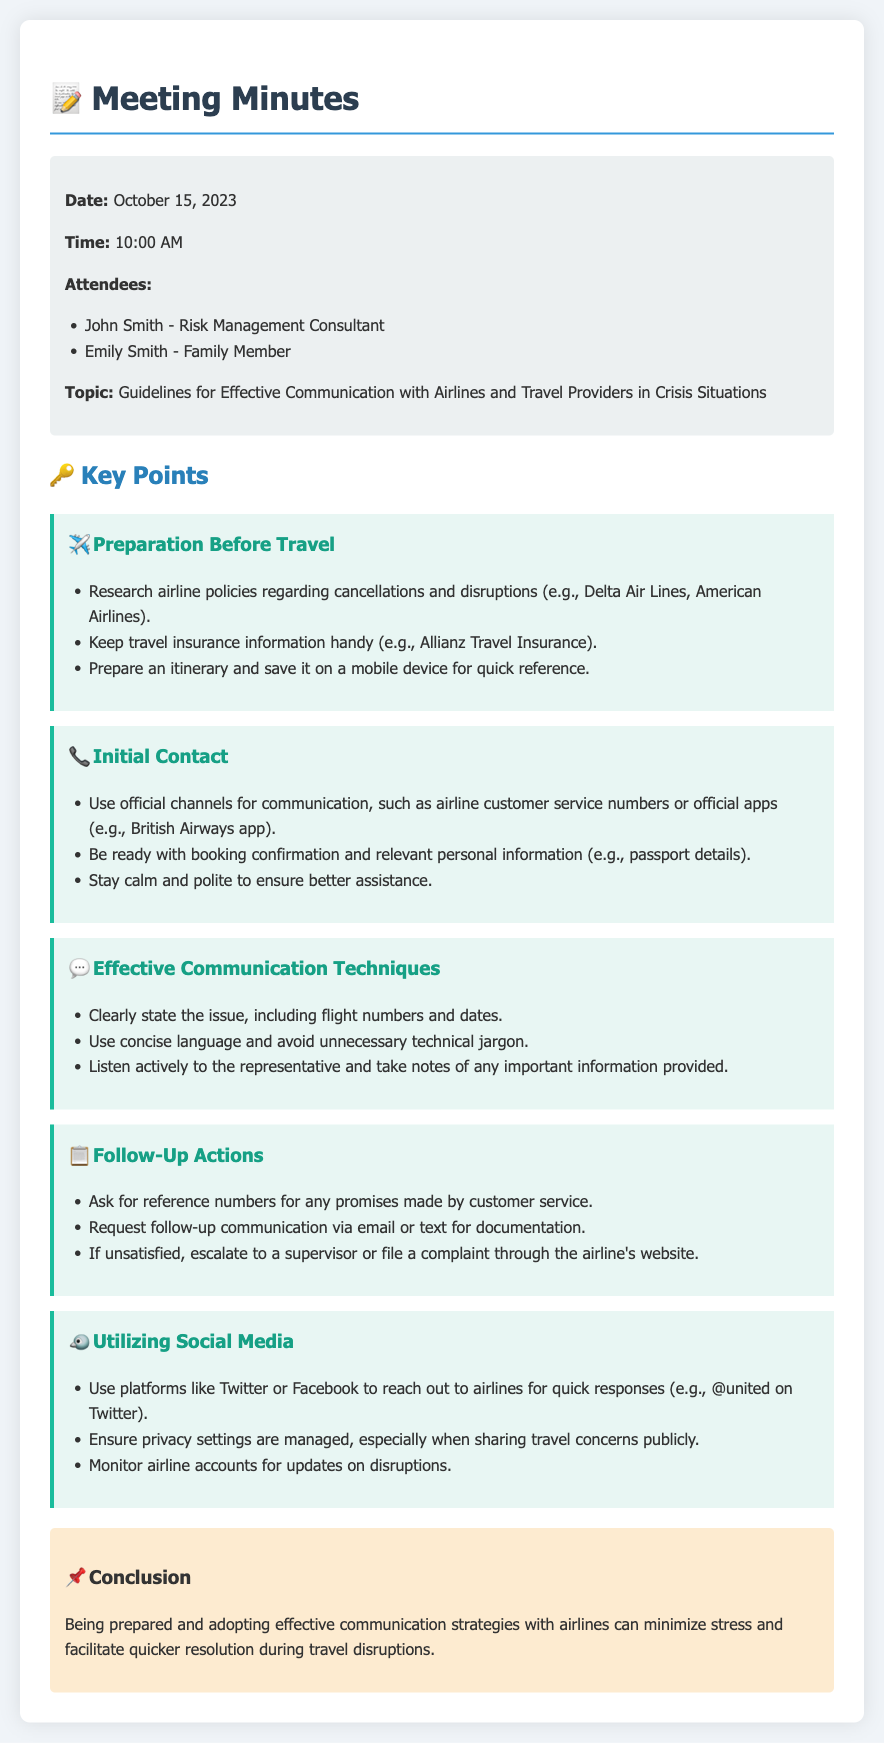what is the date of the meeting? The date of the meeting is stated in the meta-info section of the document.
Answer: October 15, 2023 who is one of the attendees? The names of attendees are listed under the meta-info section.
Answer: John Smith what is one communication channel recommended for initial contact? The document specifies using official channels for communication.
Answer: airline customer service numbers what should you keep handy before travel? The guidelines highlight the importance of keeping certain information accessible before travel.
Answer: travel insurance information what should you request for follow-up actions? The follow-up actions section advises on specific documentation to ask for.
Answer: reference numbers how can social media be utilized in crisis situations? The document outlines how social media can assist in reaching out to airlines.
Answer: quick responses what is a key effective communication technique? The document lists techniques for effective communication, including a crucial action to take.
Answer: Listen actively what should be avoided during communication? The guidelines mention avoiding certain types of language in communication.
Answer: unnecessary technical jargon what is the conclusion of the meeting minutes? The conclusion summarizes the overall advice given during the meeting.
Answer: Being prepared and adopting effective communication strategies with airlines can minimize stress and facilitate quicker resolution during travel disruptions 